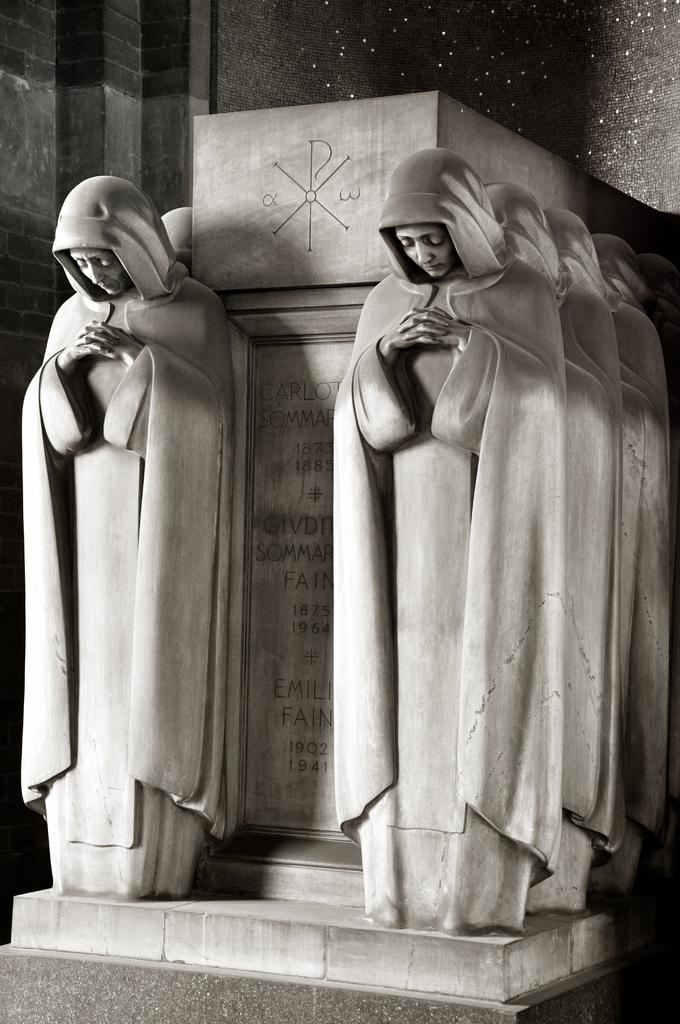What type of artwork is featured in the image? The image contains stone carving. What specific objects can be seen in the image? There are statues in the image. What additional detail can be observed on the statues? The statues have hand-carved text on them. Can you tell me how many stalks of celery are depicted on the statues? There is no celery present on the statues; they only have hand-carved text. What type of pest can be seen interacting with the statues in the image? There is no pest present in the image; the statues are stationary and have hand-carved text on them. 